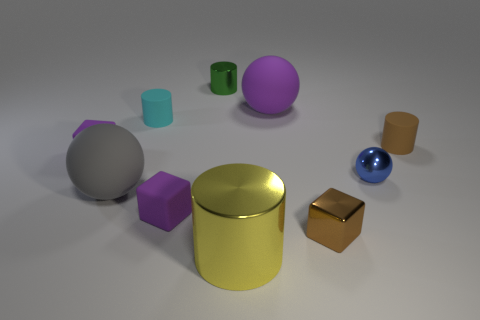What material is the small object that is the same color as the metallic block?
Offer a very short reply. Rubber. There is another tiny cylinder that is made of the same material as the brown cylinder; what color is it?
Your answer should be very brief. Cyan. Are there more rubber things than things?
Give a very brief answer. No. Are any large red rubber spheres visible?
Your response must be concise. No. What is the shape of the metallic thing on the left side of the large cylinder on the left side of the purple matte sphere?
Offer a terse response. Cylinder. What number of things are metallic cylinders or cubes that are on the left side of the small brown metal thing?
Your answer should be compact. 4. What is the color of the small rubber thing in front of the blue object behind the small rubber object that is in front of the big gray matte thing?
Provide a succinct answer. Purple. What is the material of the purple object that is the same shape as the gray thing?
Offer a terse response. Rubber. What is the color of the big cylinder?
Ensure brevity in your answer.  Yellow. Do the large metallic thing and the tiny shiny ball have the same color?
Ensure brevity in your answer.  No. 